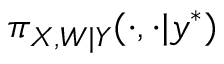Convert formula to latex. <formula><loc_0><loc_0><loc_500><loc_500>\pi _ { X , W | Y } ( \cdot , \cdot | y ^ { * } )</formula> 